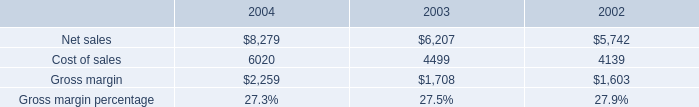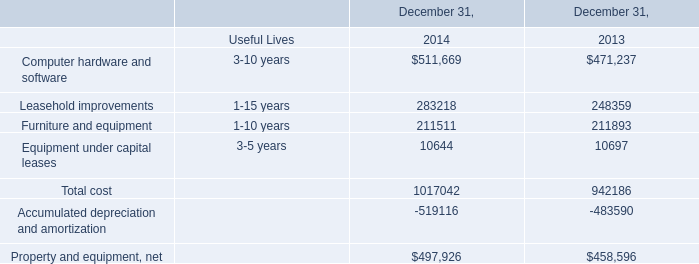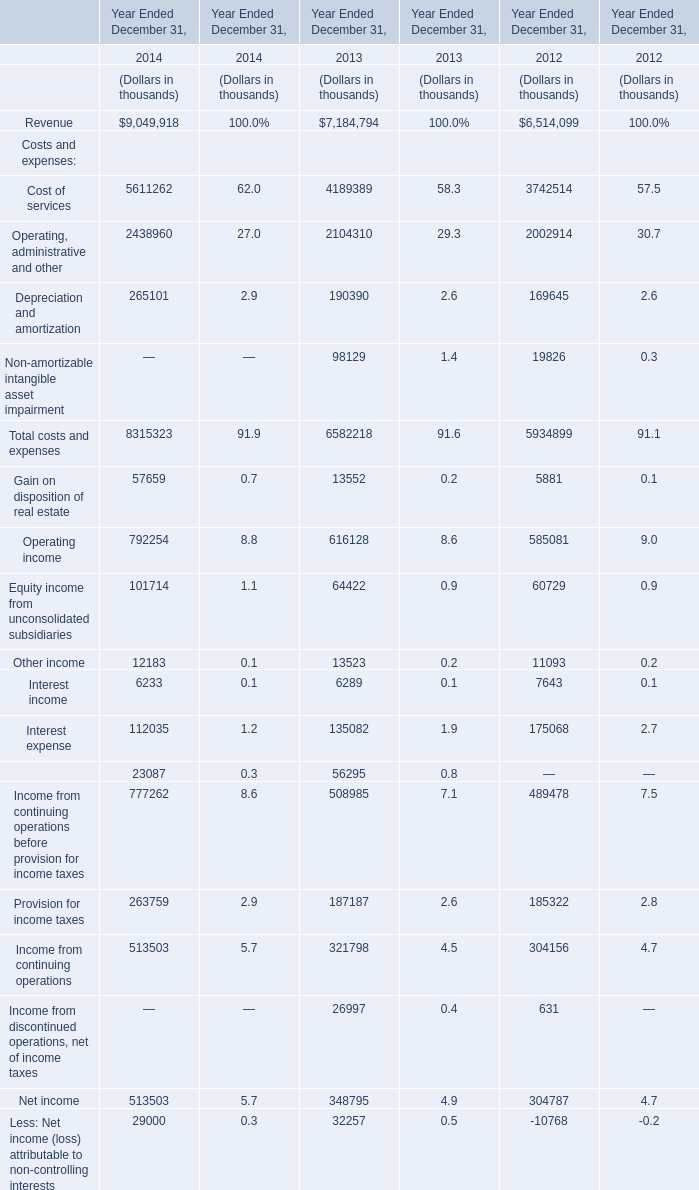What's the average of Cost of sales of 2002, and Furniture and equipment of December 31, 2013 ? 
Computations: ((4139.0 + 211893.0) / 2)
Answer: 108016.0. What's the average of the Computer hardware and software in the years where Less: Net income (loss) attributable to non-controlling interests is positive? (in thousand) 
Computations: ((511669 + 471237) / 2)
Answer: 491453.0. What is the sum of Accumulated depreciation and amortization of December 31, 2013, and Net sales of 2004 ? 
Computations: (483590.0 + 8279.0)
Answer: 491869.0. 